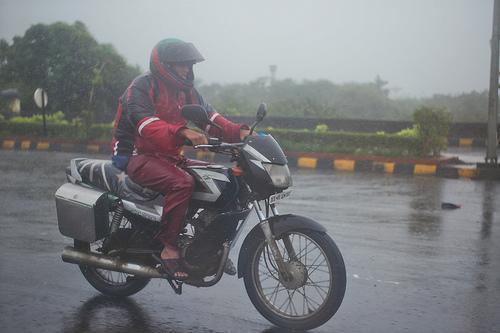How many people are pictured?
Give a very brief answer. 1. 